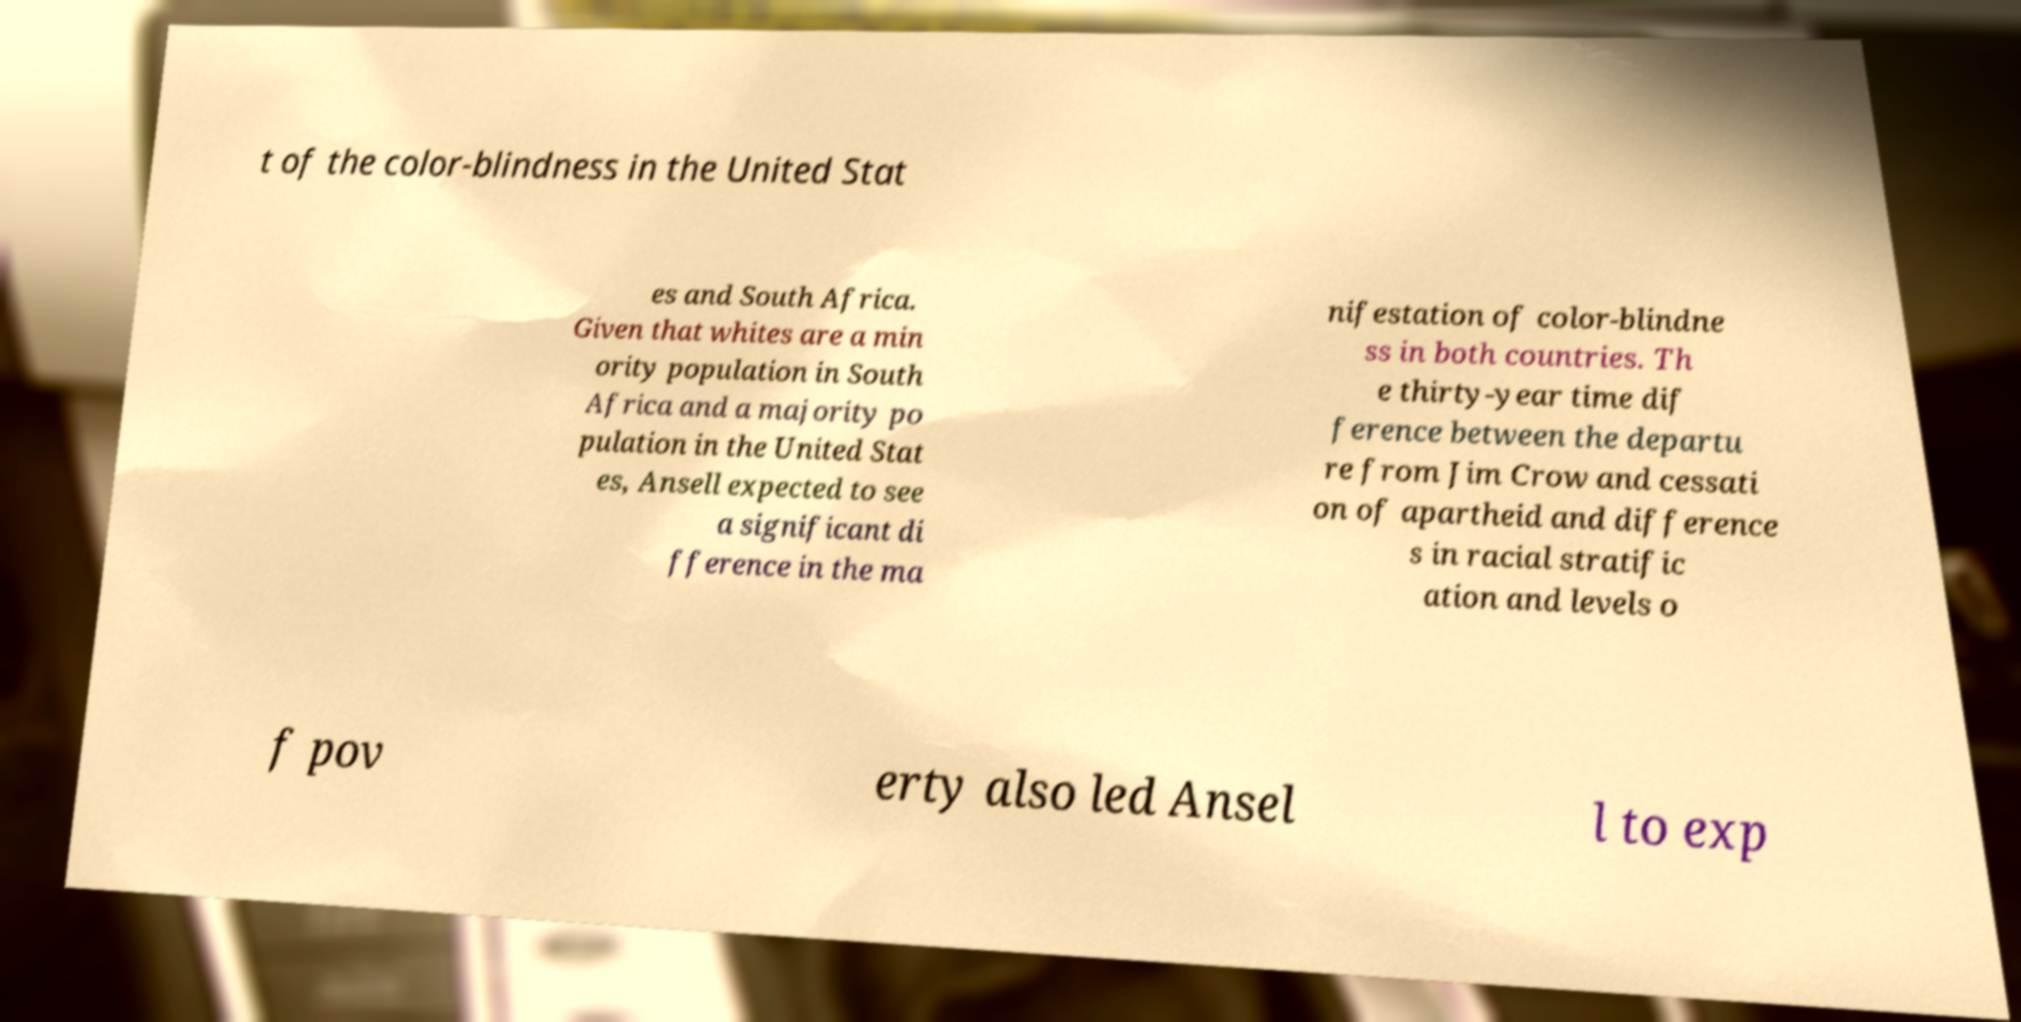Please identify and transcribe the text found in this image. t of the color-blindness in the United Stat es and South Africa. Given that whites are a min ority population in South Africa and a majority po pulation in the United Stat es, Ansell expected to see a significant di fference in the ma nifestation of color-blindne ss in both countries. Th e thirty-year time dif ference between the departu re from Jim Crow and cessati on of apartheid and difference s in racial stratific ation and levels o f pov erty also led Ansel l to exp 